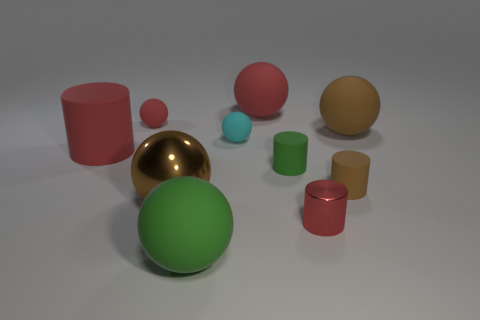There is a big sphere that is to the right of the big red sphere; what is its material?
Offer a terse response. Rubber. What material is the large cylinder?
Keep it short and to the point. Rubber. Are the cylinder that is left of the green rubber cylinder and the brown cylinder made of the same material?
Offer a terse response. Yes. Is the number of matte cylinders that are left of the big green object less than the number of large green matte spheres?
Your answer should be very brief. No. The rubber cylinder that is the same size as the green ball is what color?
Keep it short and to the point. Red. What number of other large shiny objects have the same shape as the big metal thing?
Give a very brief answer. 0. What color is the matte object in front of the small red shiny cylinder?
Provide a short and direct response. Green. What number of matte things are big green cubes or red objects?
Provide a succinct answer. 3. There is a small rubber thing that is the same color as the big matte cylinder; what is its shape?
Your answer should be compact. Sphere. How many red rubber cylinders are the same size as the brown cylinder?
Your response must be concise. 0. 